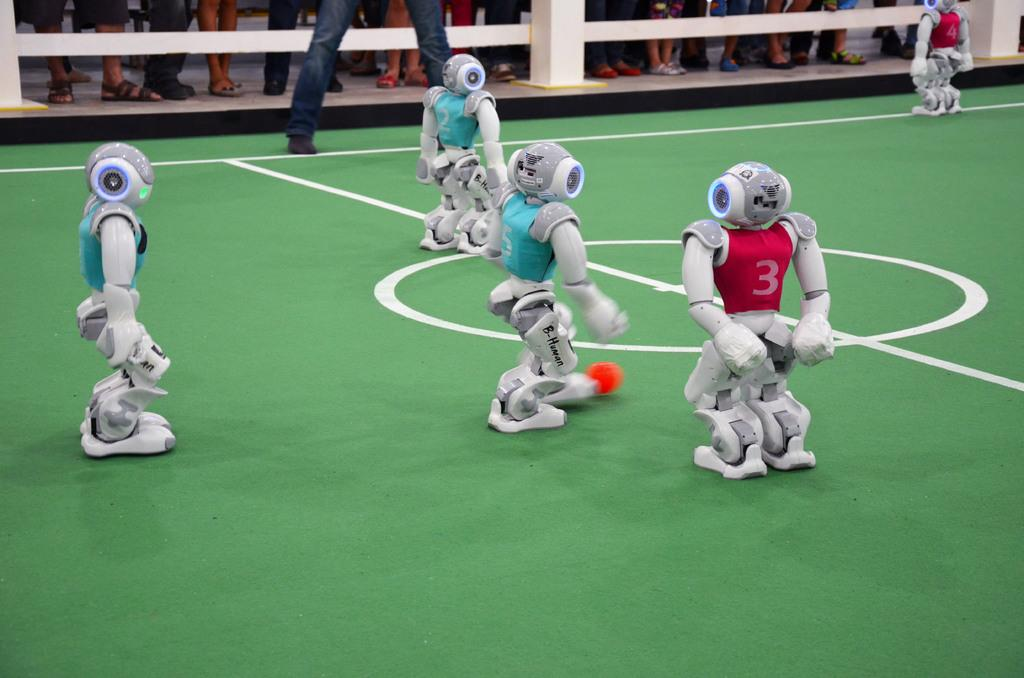<image>
Share a concise interpretation of the image provided. Several robots, one with a red jersey #3, are playing a game. 